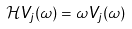<formula> <loc_0><loc_0><loc_500><loc_500>\mathcal { H } V _ { j } ( \omega ) = \omega V _ { j } ( \omega )</formula> 